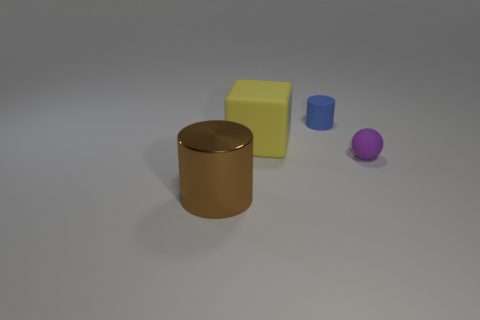Add 3 large gray shiny cubes. How many objects exist? 7 Subtract all cubes. How many objects are left? 3 Subtract all green matte balls. Subtract all small matte things. How many objects are left? 2 Add 2 yellow things. How many yellow things are left? 3 Add 4 large red metal objects. How many large red metal objects exist? 4 Subtract 1 brown cylinders. How many objects are left? 3 